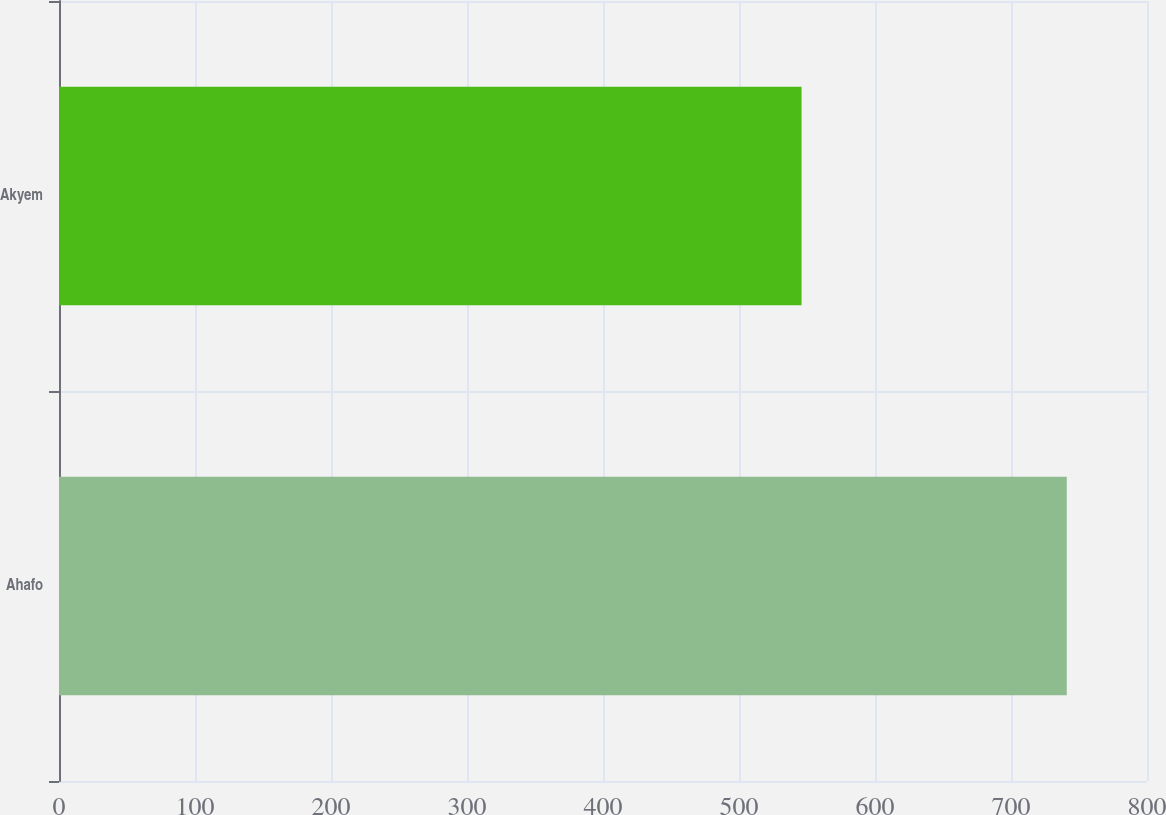<chart> <loc_0><loc_0><loc_500><loc_500><bar_chart><fcel>Ahafo<fcel>Akyem<nl><fcel>741<fcel>546<nl></chart> 